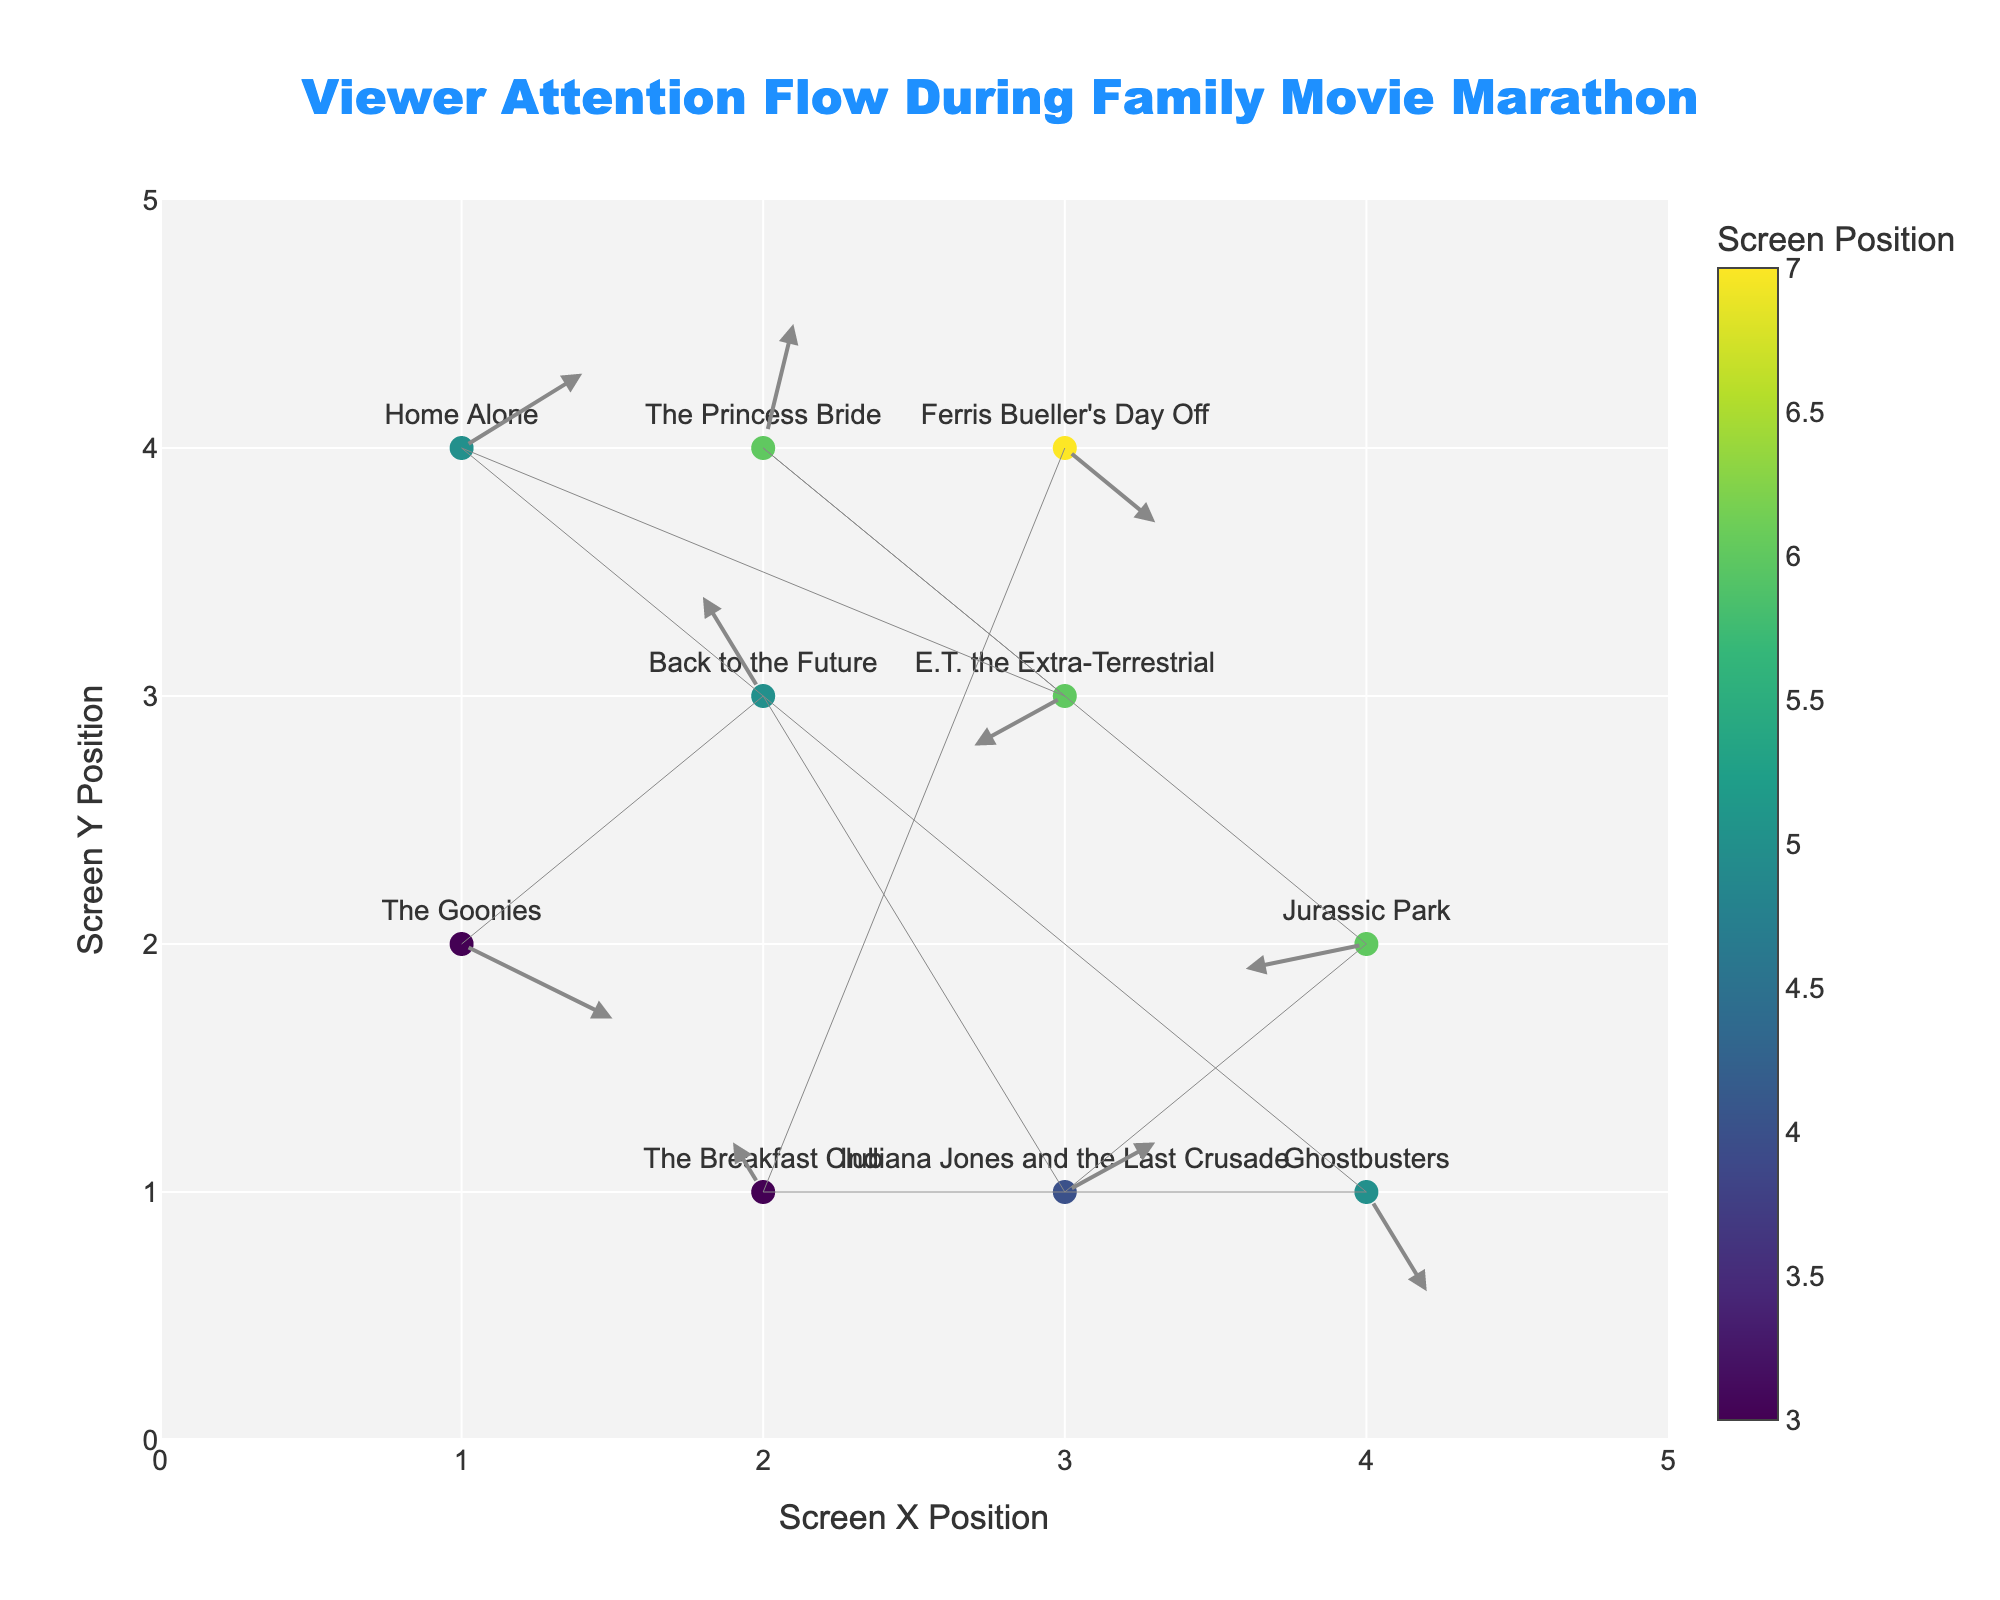What is the title of the quiver plot? The title is usually positioned at the top center of the plot. In this case, it is described as "Viewer Attention Flow During Family Movie Marathon" in the 'title' section of the layout.
Answer: Viewer Attention Flow During Family Movie Marathon Where is the screen located for "Back to the Future"? The screen location for "Back to the Future" can be determined from the x and y coordinates associated with this movie. "Back to the Future" has coordinates (2, 3). So, the screen location is (2, 3).
Answer: (2, 3) Which screen shows "Jurassic Park"? By looking at the screen coordinates for "Jurassic Park", we see that it is located at coordinates (4, 2).
Answer: (4, 2) Are there more screens located on the left side (x <= 2) or the right side (x > 2) of the plot? To answer, count the number of screens where x <= 2 and those where x > 2. The screens on the left side (x <= 2) are 3 screens ("The Goonies", "The Princess Bride", and "The Breakfast Club"). The screens on the right side (x > 2) are 7 screens ("Back to the Future", "Indiana Jones and the Last Crusade", "Jurassic Park", "E.T. the Extra-Terrestrial", "Home Alone", "Ghostbusters", and "Ferris Bueller's Day Off"). Therefore, there are more screens on the right side.
Answer: More on the right side Which movie's attention flow moves diagonally upwards to the right? Attention flow moving diagonally upwards to the right would have positive u and v vectors. Checking the data, "The Princess Bride" has a vector (0.1, 0.5), which fits this condition.
Answer: The Princess Bride Which movie's attention flow has the largest vertical movement upwards? To determine this, we should find the movie with the highest positive value in the v column. "The Princess Bride" has v = 0.5, which is the largest vertical movement upwards.
Answer: The Princess Bride What is the colorbar title in the plot? The colorbar title, as indicated in the 'colorbar' section of the marker settings, is "Screen Position".
Answer: Screen Position Which movie's attention flow starts at (1,4) and moves? We can identify this by checking the coordinate (1,4). The movie at this position is "Home Alone".
Answer: Home Alone How many screens have attention flow vectors with both negative u and v values? Checking the data for vectors with both u and v negative: "Jurassic Park" (-0.4, -0.1) and "E.T. the Extra-Terrestrial" (-0.3, -0.2). We see that there are two such screens.
Answer: 2 Which movie's attention flow moves the furthest distance? Calculate the Euclidean distance for each vector. The vector (u,v) leads to the distance √(u^2 + v^2). The largest distance is for "Home Alone" with vector (0.4, 0.3), distance: √(0.4^2 + 0.3^2) = √(0.16 + 0.09) = √0.25 = 0.5.
Answer: Home Alone 